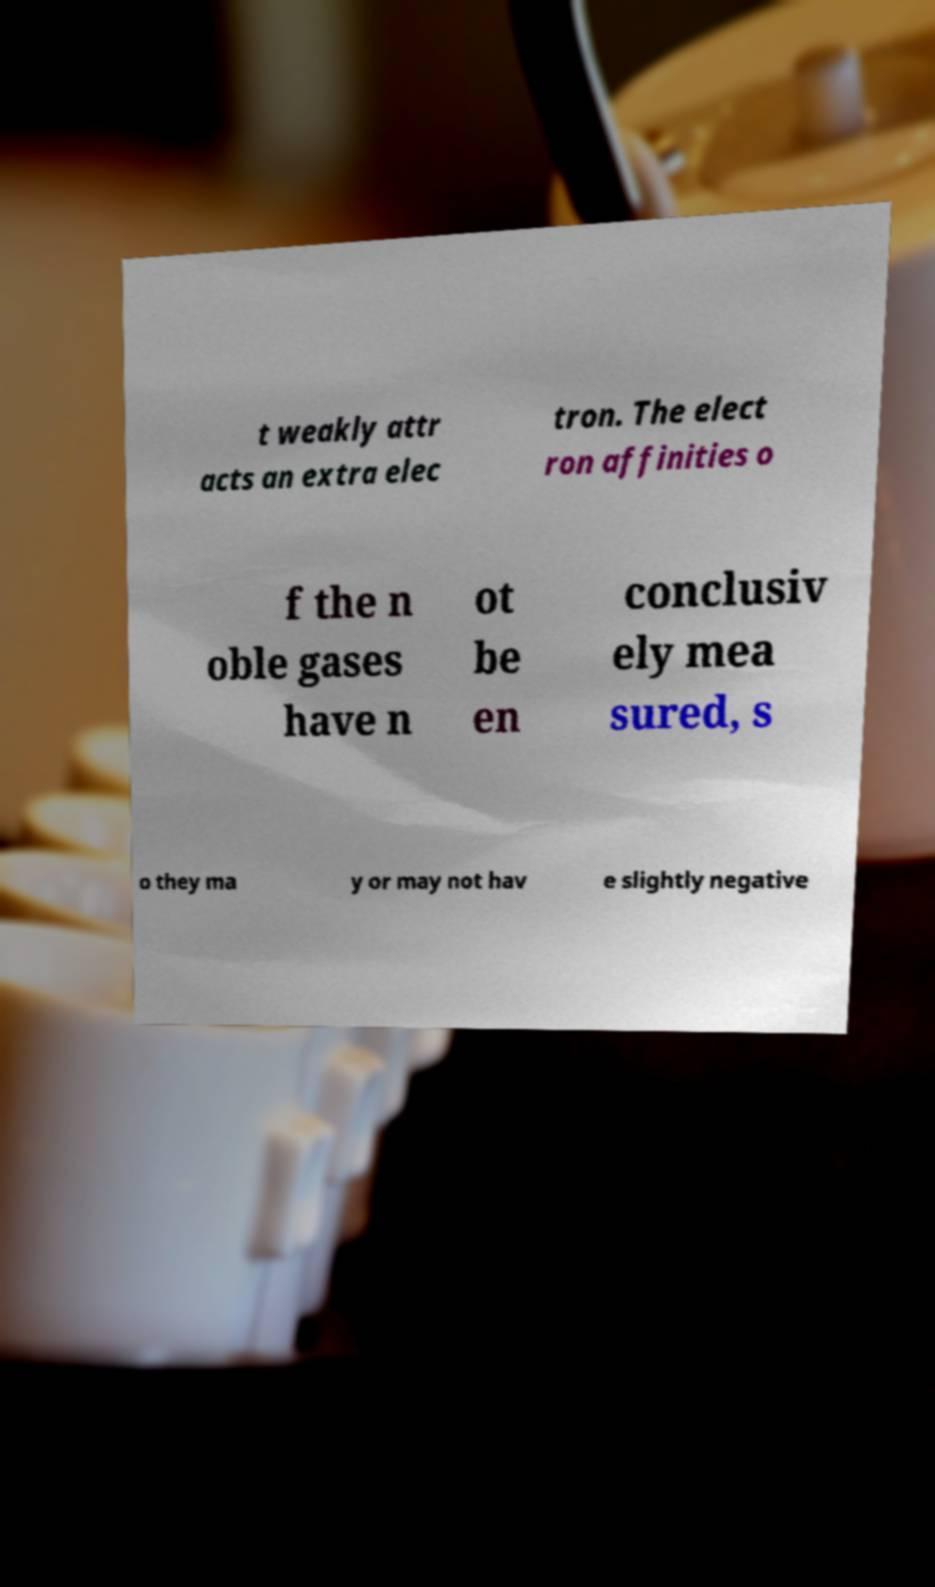Can you read and provide the text displayed in the image?This photo seems to have some interesting text. Can you extract and type it out for me? t weakly attr acts an extra elec tron. The elect ron affinities o f the n oble gases have n ot be en conclusiv ely mea sured, s o they ma y or may not hav e slightly negative 